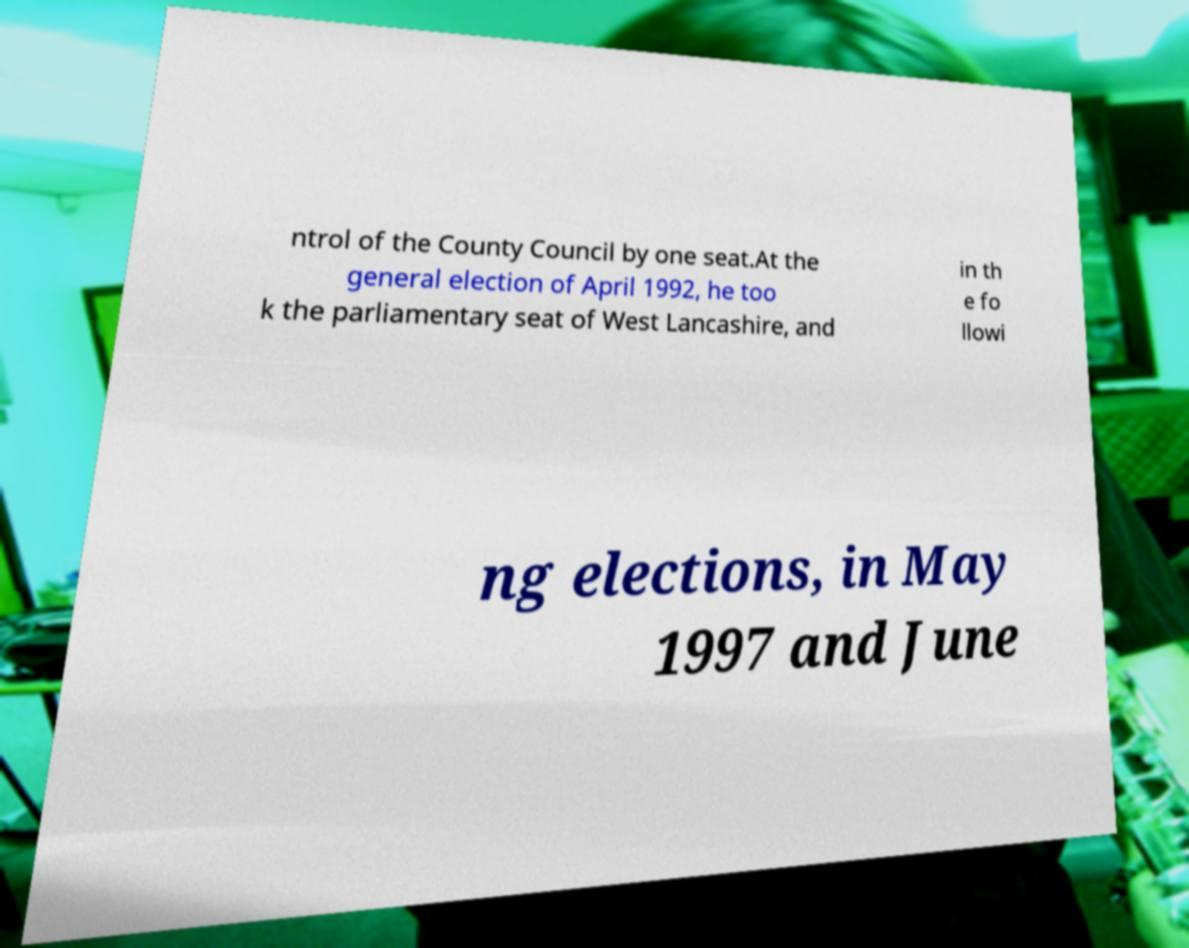I need the written content from this picture converted into text. Can you do that? ntrol of the County Council by one seat.At the general election of April 1992, he too k the parliamentary seat of West Lancashire, and in th e fo llowi ng elections, in May 1997 and June 